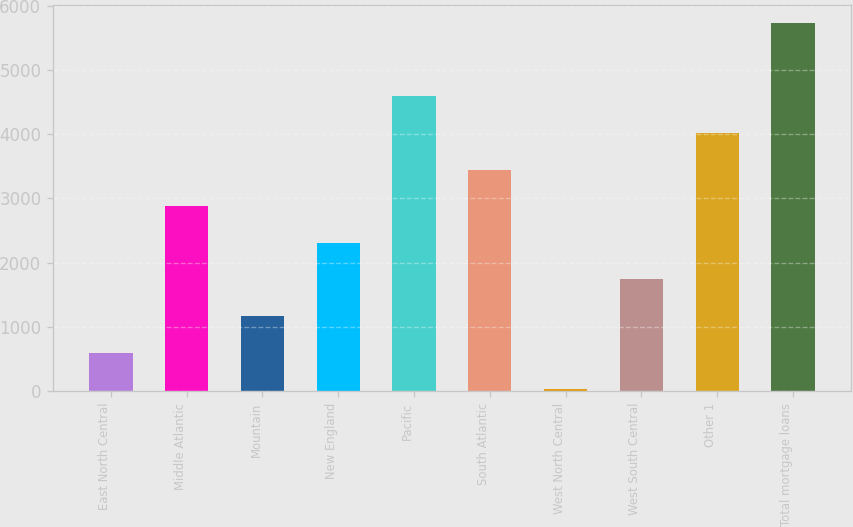Convert chart to OTSL. <chart><loc_0><loc_0><loc_500><loc_500><bar_chart><fcel>East North Central<fcel>Middle Atlantic<fcel>Mountain<fcel>New England<fcel>Pacific<fcel>South Atlantic<fcel>West North Central<fcel>West South Central<fcel>Other 1<fcel>Total mortgage loans<nl><fcel>599.8<fcel>2879<fcel>1169.6<fcel>2309.2<fcel>4588.4<fcel>3448.8<fcel>30<fcel>1739.4<fcel>4018.6<fcel>5728<nl></chart> 